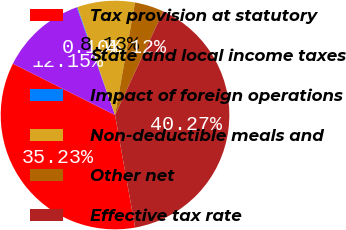Convert chart to OTSL. <chart><loc_0><loc_0><loc_500><loc_500><pie_chart><fcel>Tax provision at statutory<fcel>State and local income taxes<fcel>Impact of foreign operations<fcel>Non-deductible meals and<fcel>Other net<fcel>Effective tax rate<nl><fcel>35.23%<fcel>12.15%<fcel>0.1%<fcel>8.13%<fcel>4.12%<fcel>40.27%<nl></chart> 